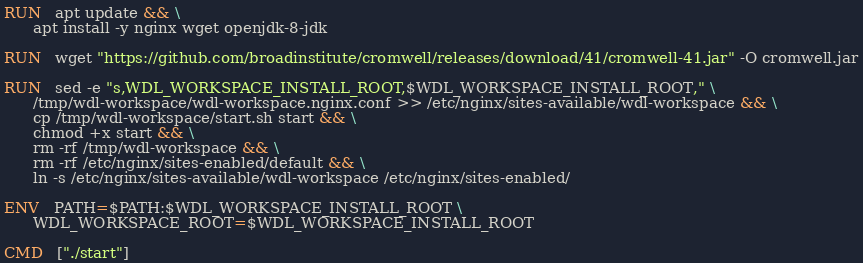<code> <loc_0><loc_0><loc_500><loc_500><_Dockerfile_>RUN   apt update && \
      apt install -y nginx wget openjdk-8-jdk

RUN   wget "https://github.com/broadinstitute/cromwell/releases/download/41/cromwell-41.jar" -O cromwell.jar

RUN   sed -e "s,WDL_WORKSPACE_INSTALL_ROOT,$WDL_WORKSPACE_INSTALL_ROOT," \
      /tmp/wdl-workspace/wdl-workspace.nginx.conf >> /etc/nginx/sites-available/wdl-workspace && \
      cp /tmp/wdl-workspace/start.sh start && \
      chmod +x start && \
      rm -rf /tmp/wdl-workspace && \
      rm -rf /etc/nginx/sites-enabled/default && \
      ln -s /etc/nginx/sites-available/wdl-workspace /etc/nginx/sites-enabled/

ENV   PATH=$PATH:$WDL_WORKSPACE_INSTALL_ROOT \
      WDL_WORKSPACE_ROOT=$WDL_WORKSPACE_INSTALL_ROOT

CMD   ["./start"]
</code> 